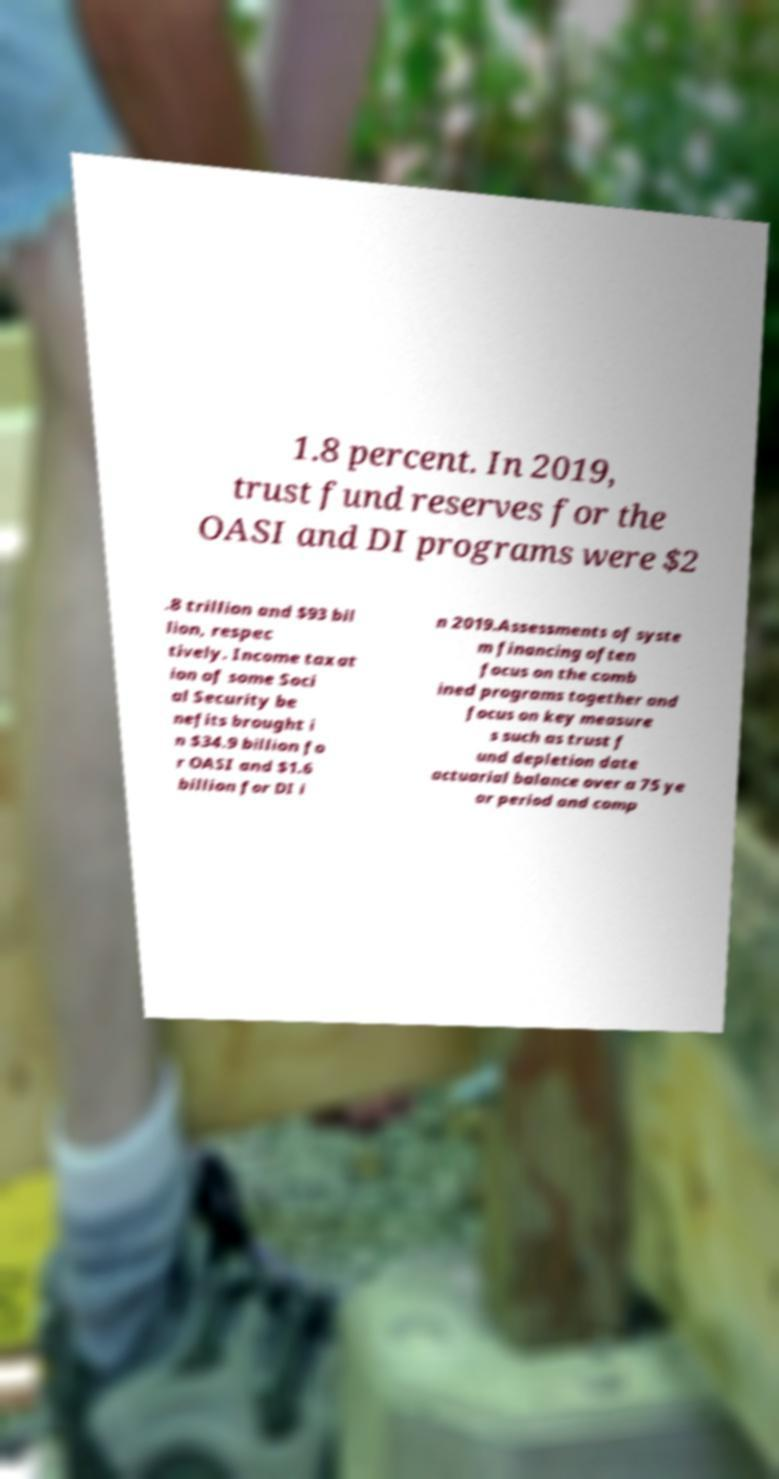For documentation purposes, I need the text within this image transcribed. Could you provide that? 1.8 percent. In 2019, trust fund reserves for the OASI and DI programs were $2 .8 trillion and $93 bil lion, respec tively. Income taxat ion of some Soci al Security be nefits brought i n $34.9 billion fo r OASI and $1.6 billion for DI i n 2019.Assessments of syste m financing often focus on the comb ined programs together and focus on key measure s such as trust f und depletion date actuarial balance over a 75 ye ar period and comp 